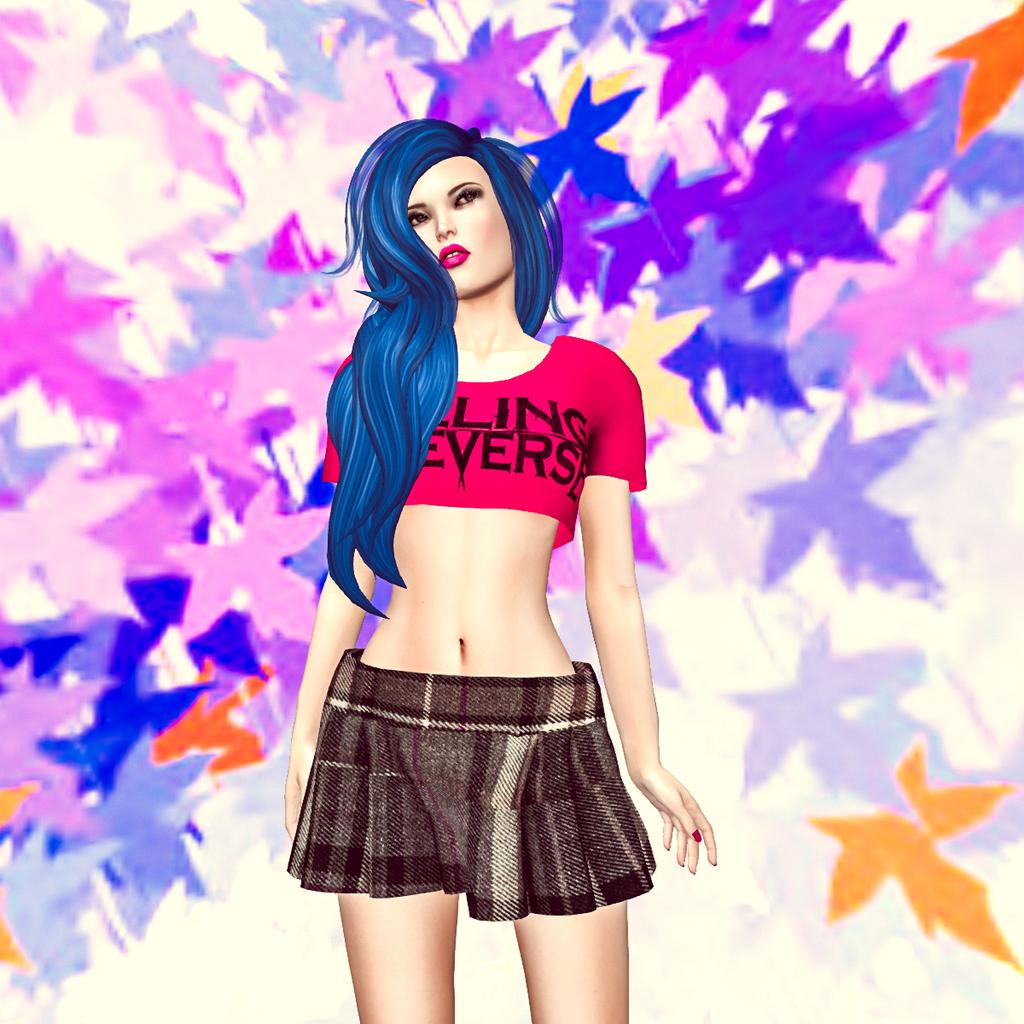What words are on her shirt?
Keep it short and to the point. Unanswerable. 